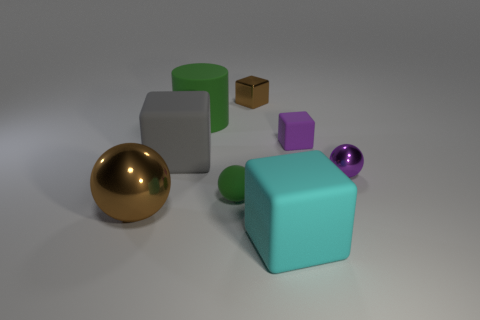Add 1 big blue matte objects. How many objects exist? 9 Subtract all shiny spheres. How many spheres are left? 1 Subtract all purple blocks. How many blocks are left? 3 Subtract 2 cubes. How many cubes are left? 2 Subtract all cylinders. How many objects are left? 7 Subtract all blue cylinders. Subtract all green blocks. How many cylinders are left? 1 Subtract all green cylinders. How many yellow cubes are left? 0 Subtract all big cyan cubes. Subtract all large green cylinders. How many objects are left? 6 Add 3 cyan matte things. How many cyan matte things are left? 4 Add 2 metal blocks. How many metal blocks exist? 3 